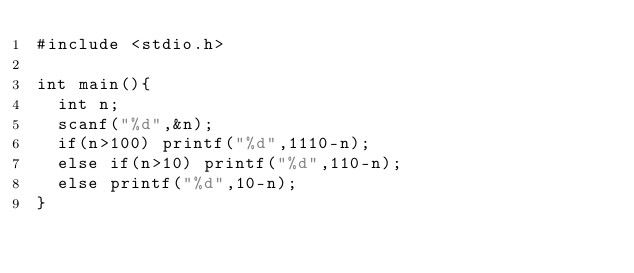Convert code to text. <code><loc_0><loc_0><loc_500><loc_500><_C_>#include <stdio.h>

int main(){
  int n;
  scanf("%d",&n);
  if(n>100) printf("%d",1110-n);
  else if(n>10) printf("%d",110-n);
  else printf("%d",10-n);
}</code> 